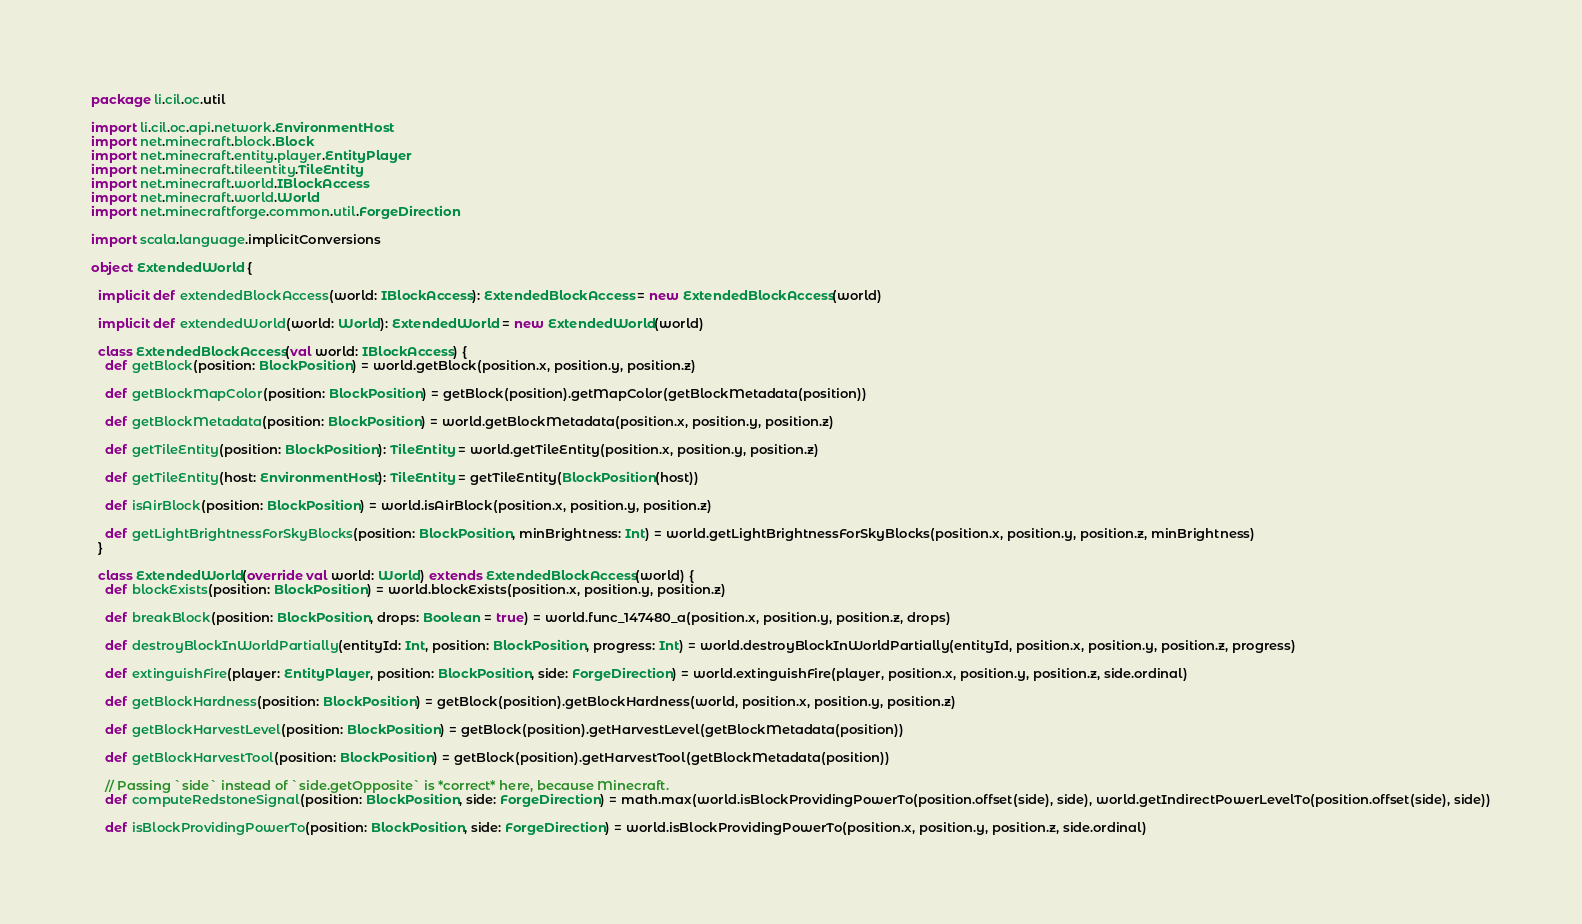<code> <loc_0><loc_0><loc_500><loc_500><_Scala_>package li.cil.oc.util

import li.cil.oc.api.network.EnvironmentHost
import net.minecraft.block.Block
import net.minecraft.entity.player.EntityPlayer
import net.minecraft.tileentity.TileEntity
import net.minecraft.world.IBlockAccess
import net.minecraft.world.World
import net.minecraftforge.common.util.ForgeDirection

import scala.language.implicitConversions

object ExtendedWorld {

  implicit def extendedBlockAccess(world: IBlockAccess): ExtendedBlockAccess = new ExtendedBlockAccess(world)

  implicit def extendedWorld(world: World): ExtendedWorld = new ExtendedWorld(world)

  class ExtendedBlockAccess(val world: IBlockAccess) {
    def getBlock(position: BlockPosition) = world.getBlock(position.x, position.y, position.z)

    def getBlockMapColor(position: BlockPosition) = getBlock(position).getMapColor(getBlockMetadata(position))

    def getBlockMetadata(position: BlockPosition) = world.getBlockMetadata(position.x, position.y, position.z)

    def getTileEntity(position: BlockPosition): TileEntity = world.getTileEntity(position.x, position.y, position.z)

    def getTileEntity(host: EnvironmentHost): TileEntity = getTileEntity(BlockPosition(host))

    def isAirBlock(position: BlockPosition) = world.isAirBlock(position.x, position.y, position.z)

    def getLightBrightnessForSkyBlocks(position: BlockPosition, minBrightness: Int) = world.getLightBrightnessForSkyBlocks(position.x, position.y, position.z, minBrightness)
  }

  class ExtendedWorld(override val world: World) extends ExtendedBlockAccess(world) {
    def blockExists(position: BlockPosition) = world.blockExists(position.x, position.y, position.z)

    def breakBlock(position: BlockPosition, drops: Boolean = true) = world.func_147480_a(position.x, position.y, position.z, drops)

    def destroyBlockInWorldPartially(entityId: Int, position: BlockPosition, progress: Int) = world.destroyBlockInWorldPartially(entityId, position.x, position.y, position.z, progress)

    def extinguishFire(player: EntityPlayer, position: BlockPosition, side: ForgeDirection) = world.extinguishFire(player, position.x, position.y, position.z, side.ordinal)

    def getBlockHardness(position: BlockPosition) = getBlock(position).getBlockHardness(world, position.x, position.y, position.z)

    def getBlockHarvestLevel(position: BlockPosition) = getBlock(position).getHarvestLevel(getBlockMetadata(position))

    def getBlockHarvestTool(position: BlockPosition) = getBlock(position).getHarvestTool(getBlockMetadata(position))

    // Passing `side` instead of `side.getOpposite` is *correct* here, because Minecraft.
    def computeRedstoneSignal(position: BlockPosition, side: ForgeDirection) = math.max(world.isBlockProvidingPowerTo(position.offset(side), side), world.getIndirectPowerLevelTo(position.offset(side), side))

    def isBlockProvidingPowerTo(position: BlockPosition, side: ForgeDirection) = world.isBlockProvidingPowerTo(position.x, position.y, position.z, side.ordinal)
</code> 